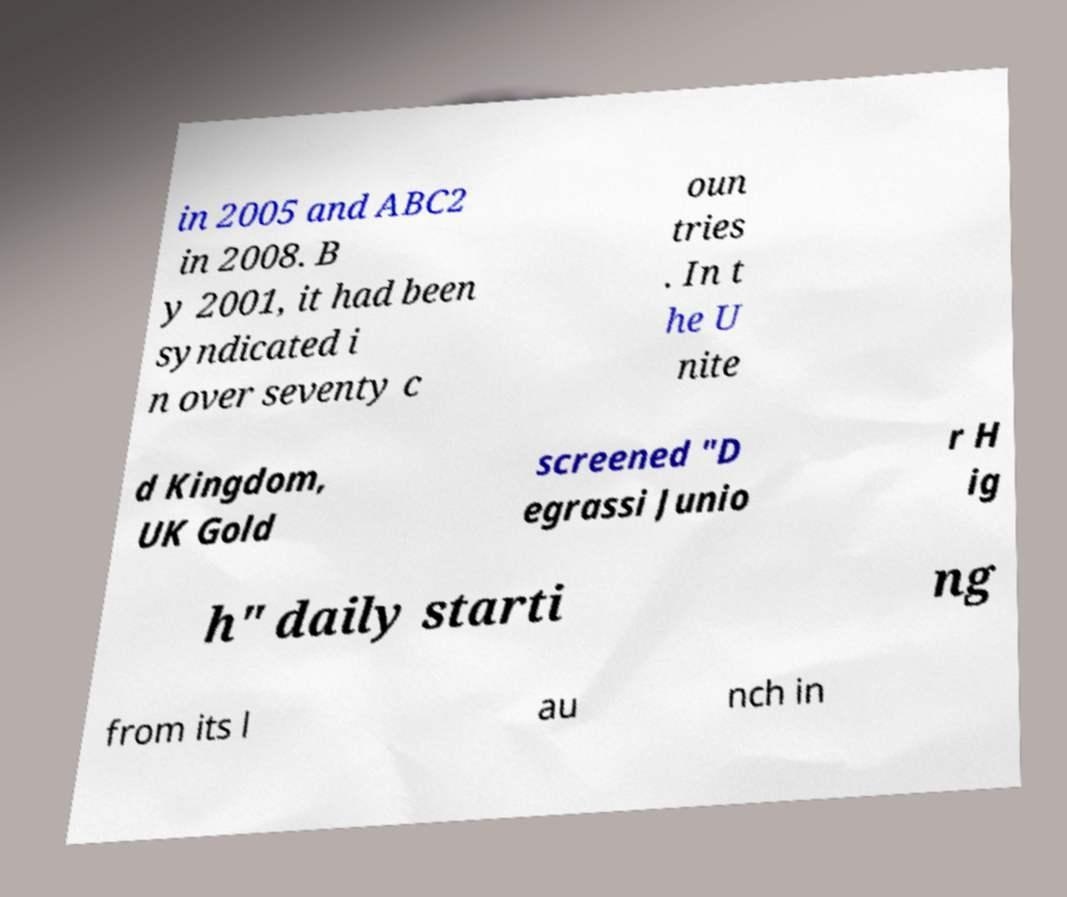Could you extract and type out the text from this image? in 2005 and ABC2 in 2008. B y 2001, it had been syndicated i n over seventy c oun tries . In t he U nite d Kingdom, UK Gold screened "D egrassi Junio r H ig h" daily starti ng from its l au nch in 